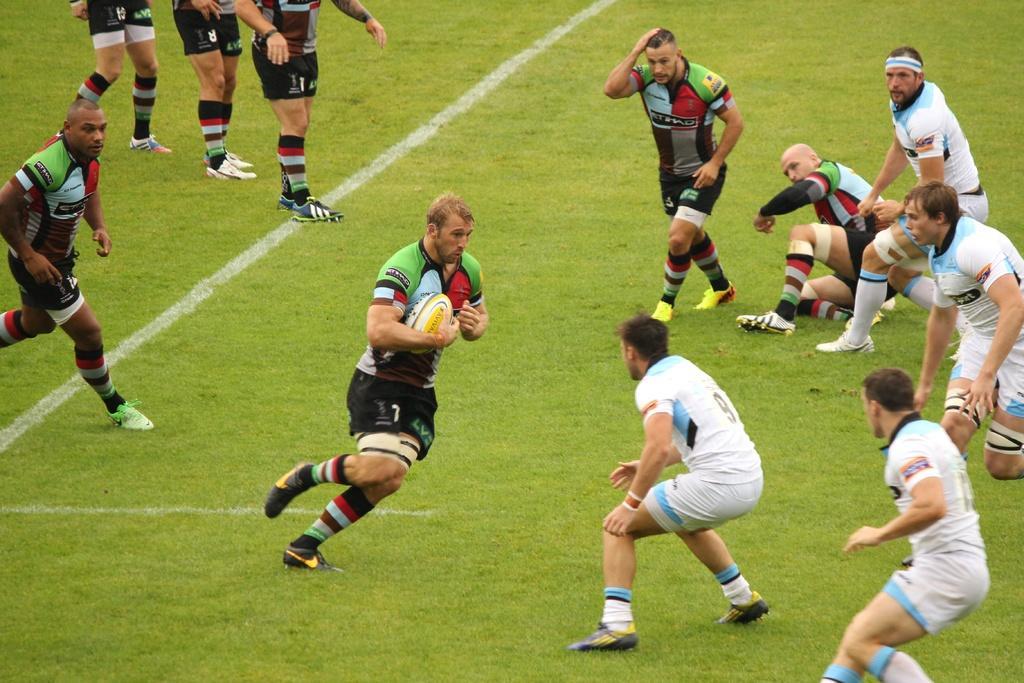Describe this image in one or two sentences. A group of people are standing on a grass. This people are running, as there is a leg movement. This man is holding a ball. 